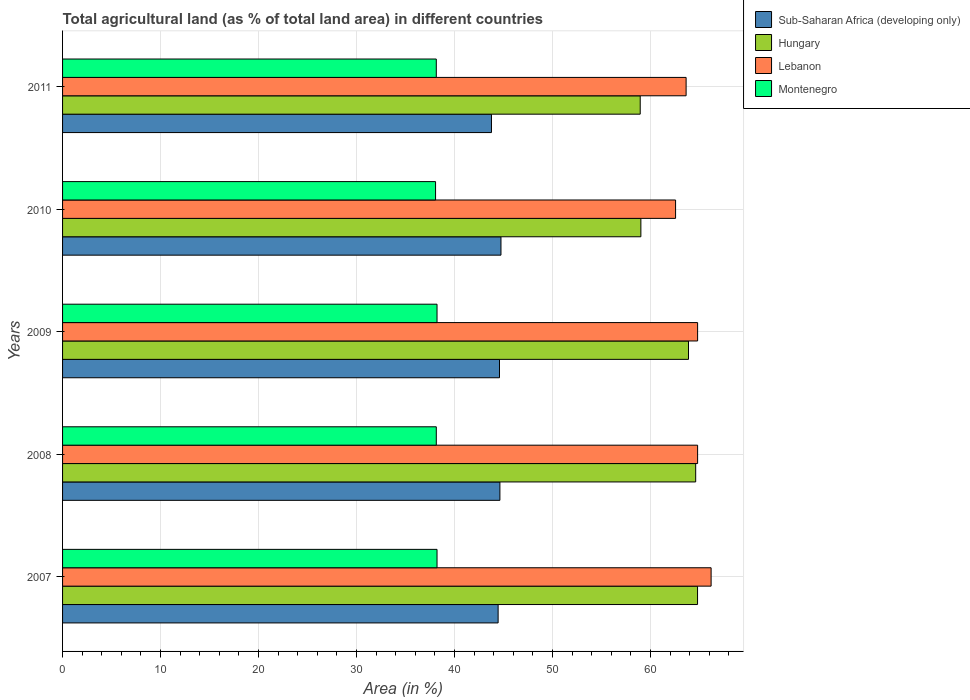How many groups of bars are there?
Give a very brief answer. 5. Are the number of bars per tick equal to the number of legend labels?
Give a very brief answer. Yes. What is the percentage of agricultural land in Hungary in 2011?
Your answer should be very brief. 58.95. Across all years, what is the maximum percentage of agricultural land in Hungary?
Your response must be concise. 64.8. Across all years, what is the minimum percentage of agricultural land in Hungary?
Give a very brief answer. 58.95. In which year was the percentage of agricultural land in Montenegro maximum?
Offer a terse response. 2007. In which year was the percentage of agricultural land in Hungary minimum?
Make the answer very short. 2011. What is the total percentage of agricultural land in Lebanon in the graph?
Make the answer very short. 322. What is the difference between the percentage of agricultural land in Lebanon in 2009 and that in 2011?
Offer a terse response. 1.17. What is the difference between the percentage of agricultural land in Sub-Saharan Africa (developing only) in 2011 and the percentage of agricultural land in Hungary in 2008?
Give a very brief answer. -20.84. What is the average percentage of agricultural land in Sub-Saharan Africa (developing only) per year?
Keep it short and to the point. 44.44. In the year 2007, what is the difference between the percentage of agricultural land in Hungary and percentage of agricultural land in Sub-Saharan Africa (developing only)?
Your response must be concise. 20.35. What is the ratio of the percentage of agricultural land in Montenegro in 2010 to that in 2011?
Make the answer very short. 1. Is the difference between the percentage of agricultural land in Hungary in 2007 and 2008 greater than the difference between the percentage of agricultural land in Sub-Saharan Africa (developing only) in 2007 and 2008?
Keep it short and to the point. Yes. What is the difference between the highest and the second highest percentage of agricultural land in Sub-Saharan Africa (developing only)?
Offer a terse response. 0.11. What is the difference between the highest and the lowest percentage of agricultural land in Sub-Saharan Africa (developing only)?
Ensure brevity in your answer.  0.97. In how many years, is the percentage of agricultural land in Montenegro greater than the average percentage of agricultural land in Montenegro taken over all years?
Provide a short and direct response. 2. Is the sum of the percentage of agricultural land in Hungary in 2008 and 2010 greater than the maximum percentage of agricultural land in Lebanon across all years?
Give a very brief answer. Yes. Is it the case that in every year, the sum of the percentage of agricultural land in Lebanon and percentage of agricultural land in Hungary is greater than the sum of percentage of agricultural land in Sub-Saharan Africa (developing only) and percentage of agricultural land in Montenegro?
Give a very brief answer. Yes. What does the 3rd bar from the top in 2010 represents?
Provide a succinct answer. Hungary. What does the 1st bar from the bottom in 2009 represents?
Keep it short and to the point. Sub-Saharan Africa (developing only). How many bars are there?
Give a very brief answer. 20. Does the graph contain grids?
Provide a short and direct response. Yes. Where does the legend appear in the graph?
Your answer should be very brief. Top right. How many legend labels are there?
Offer a very short reply. 4. How are the legend labels stacked?
Your answer should be very brief. Vertical. What is the title of the graph?
Your answer should be compact. Total agricultural land (as % of total land area) in different countries. What is the label or title of the X-axis?
Your answer should be very brief. Area (in %). What is the Area (in %) in Sub-Saharan Africa (developing only) in 2007?
Your response must be concise. 44.45. What is the Area (in %) in Hungary in 2007?
Keep it short and to the point. 64.8. What is the Area (in %) in Lebanon in 2007?
Offer a terse response. 66.19. What is the Area (in %) in Montenegro in 2007?
Offer a terse response. 38.22. What is the Area (in %) of Sub-Saharan Africa (developing only) in 2008?
Keep it short and to the point. 44.63. What is the Area (in %) of Hungary in 2008?
Your answer should be compact. 64.61. What is the Area (in %) of Lebanon in 2008?
Offer a terse response. 64.81. What is the Area (in %) of Montenegro in 2008?
Your answer should be very brief. 38.14. What is the Area (in %) in Sub-Saharan Africa (developing only) in 2009?
Your answer should be very brief. 44.59. What is the Area (in %) of Hungary in 2009?
Provide a succinct answer. 63.88. What is the Area (in %) in Lebanon in 2009?
Ensure brevity in your answer.  64.81. What is the Area (in %) in Montenegro in 2009?
Make the answer very short. 38.22. What is the Area (in %) in Sub-Saharan Africa (developing only) in 2010?
Keep it short and to the point. 44.74. What is the Area (in %) of Hungary in 2010?
Give a very brief answer. 59.02. What is the Area (in %) in Lebanon in 2010?
Keep it short and to the point. 62.56. What is the Area (in %) of Montenegro in 2010?
Give a very brief answer. 38.07. What is the Area (in %) in Sub-Saharan Africa (developing only) in 2011?
Provide a succinct answer. 43.77. What is the Area (in %) in Hungary in 2011?
Make the answer very short. 58.95. What is the Area (in %) in Lebanon in 2011?
Provide a succinct answer. 63.64. What is the Area (in %) of Montenegro in 2011?
Your answer should be very brief. 38.14. Across all years, what is the maximum Area (in %) of Sub-Saharan Africa (developing only)?
Ensure brevity in your answer.  44.74. Across all years, what is the maximum Area (in %) of Hungary?
Offer a terse response. 64.8. Across all years, what is the maximum Area (in %) of Lebanon?
Ensure brevity in your answer.  66.19. Across all years, what is the maximum Area (in %) of Montenegro?
Keep it short and to the point. 38.22. Across all years, what is the minimum Area (in %) in Sub-Saharan Africa (developing only)?
Your response must be concise. 43.77. Across all years, what is the minimum Area (in %) in Hungary?
Provide a short and direct response. 58.95. Across all years, what is the minimum Area (in %) of Lebanon?
Provide a short and direct response. 62.56. Across all years, what is the minimum Area (in %) in Montenegro?
Your answer should be compact. 38.07. What is the total Area (in %) in Sub-Saharan Africa (developing only) in the graph?
Ensure brevity in your answer.  222.19. What is the total Area (in %) in Hungary in the graph?
Keep it short and to the point. 311.27. What is the total Area (in %) in Lebanon in the graph?
Your answer should be very brief. 322. What is the total Area (in %) in Montenegro in the graph?
Offer a terse response. 190.78. What is the difference between the Area (in %) in Sub-Saharan Africa (developing only) in 2007 and that in 2008?
Offer a very short reply. -0.18. What is the difference between the Area (in %) in Hungary in 2007 and that in 2008?
Give a very brief answer. 0.19. What is the difference between the Area (in %) in Lebanon in 2007 and that in 2008?
Give a very brief answer. 1.38. What is the difference between the Area (in %) of Montenegro in 2007 and that in 2008?
Offer a terse response. 0.07. What is the difference between the Area (in %) of Sub-Saharan Africa (developing only) in 2007 and that in 2009?
Offer a terse response. -0.14. What is the difference between the Area (in %) of Hungary in 2007 and that in 2009?
Offer a very short reply. 0.92. What is the difference between the Area (in %) of Lebanon in 2007 and that in 2009?
Make the answer very short. 1.38. What is the difference between the Area (in %) of Montenegro in 2007 and that in 2009?
Provide a succinct answer. 0. What is the difference between the Area (in %) of Sub-Saharan Africa (developing only) in 2007 and that in 2010?
Provide a succinct answer. -0.29. What is the difference between the Area (in %) of Hungary in 2007 and that in 2010?
Provide a short and direct response. 5.78. What is the difference between the Area (in %) in Lebanon in 2007 and that in 2010?
Your answer should be very brief. 3.63. What is the difference between the Area (in %) of Montenegro in 2007 and that in 2010?
Offer a very short reply. 0.15. What is the difference between the Area (in %) in Sub-Saharan Africa (developing only) in 2007 and that in 2011?
Your answer should be very brief. 0.68. What is the difference between the Area (in %) in Hungary in 2007 and that in 2011?
Keep it short and to the point. 5.85. What is the difference between the Area (in %) in Lebanon in 2007 and that in 2011?
Ensure brevity in your answer.  2.55. What is the difference between the Area (in %) in Montenegro in 2007 and that in 2011?
Provide a succinct answer. 0.07. What is the difference between the Area (in %) of Sub-Saharan Africa (developing only) in 2008 and that in 2009?
Your response must be concise. 0.04. What is the difference between the Area (in %) in Hungary in 2008 and that in 2009?
Your response must be concise. 0.73. What is the difference between the Area (in %) in Montenegro in 2008 and that in 2009?
Provide a succinct answer. -0.07. What is the difference between the Area (in %) of Sub-Saharan Africa (developing only) in 2008 and that in 2010?
Provide a succinct answer. -0.11. What is the difference between the Area (in %) in Hungary in 2008 and that in 2010?
Keep it short and to the point. 5.59. What is the difference between the Area (in %) of Lebanon in 2008 and that in 2010?
Offer a terse response. 2.25. What is the difference between the Area (in %) of Montenegro in 2008 and that in 2010?
Provide a succinct answer. 0.07. What is the difference between the Area (in %) of Sub-Saharan Africa (developing only) in 2008 and that in 2011?
Keep it short and to the point. 0.86. What is the difference between the Area (in %) in Hungary in 2008 and that in 2011?
Your answer should be very brief. 5.66. What is the difference between the Area (in %) in Lebanon in 2008 and that in 2011?
Provide a short and direct response. 1.17. What is the difference between the Area (in %) in Montenegro in 2008 and that in 2011?
Keep it short and to the point. 0. What is the difference between the Area (in %) of Sub-Saharan Africa (developing only) in 2009 and that in 2010?
Your response must be concise. -0.15. What is the difference between the Area (in %) of Hungary in 2009 and that in 2010?
Give a very brief answer. 4.86. What is the difference between the Area (in %) of Lebanon in 2009 and that in 2010?
Ensure brevity in your answer.  2.25. What is the difference between the Area (in %) of Montenegro in 2009 and that in 2010?
Give a very brief answer. 0.15. What is the difference between the Area (in %) in Sub-Saharan Africa (developing only) in 2009 and that in 2011?
Offer a terse response. 0.82. What is the difference between the Area (in %) of Hungary in 2009 and that in 2011?
Keep it short and to the point. 4.93. What is the difference between the Area (in %) in Lebanon in 2009 and that in 2011?
Offer a terse response. 1.17. What is the difference between the Area (in %) of Montenegro in 2009 and that in 2011?
Your answer should be compact. 0.07. What is the difference between the Area (in %) of Sub-Saharan Africa (developing only) in 2010 and that in 2011?
Provide a succinct answer. 0.97. What is the difference between the Area (in %) in Hungary in 2010 and that in 2011?
Offer a very short reply. 0.07. What is the difference between the Area (in %) in Lebanon in 2010 and that in 2011?
Make the answer very short. -1.08. What is the difference between the Area (in %) in Montenegro in 2010 and that in 2011?
Your answer should be very brief. -0.07. What is the difference between the Area (in %) in Sub-Saharan Africa (developing only) in 2007 and the Area (in %) in Hungary in 2008?
Offer a very short reply. -20.16. What is the difference between the Area (in %) in Sub-Saharan Africa (developing only) in 2007 and the Area (in %) in Lebanon in 2008?
Make the answer very short. -20.36. What is the difference between the Area (in %) of Sub-Saharan Africa (developing only) in 2007 and the Area (in %) of Montenegro in 2008?
Provide a succinct answer. 6.31. What is the difference between the Area (in %) in Hungary in 2007 and the Area (in %) in Lebanon in 2008?
Give a very brief answer. -0.01. What is the difference between the Area (in %) in Hungary in 2007 and the Area (in %) in Montenegro in 2008?
Provide a succinct answer. 26.66. What is the difference between the Area (in %) of Lebanon in 2007 and the Area (in %) of Montenegro in 2008?
Your response must be concise. 28.05. What is the difference between the Area (in %) in Sub-Saharan Africa (developing only) in 2007 and the Area (in %) in Hungary in 2009?
Give a very brief answer. -19.43. What is the difference between the Area (in %) of Sub-Saharan Africa (developing only) in 2007 and the Area (in %) of Lebanon in 2009?
Your answer should be compact. -20.36. What is the difference between the Area (in %) of Sub-Saharan Africa (developing only) in 2007 and the Area (in %) of Montenegro in 2009?
Provide a short and direct response. 6.23. What is the difference between the Area (in %) of Hungary in 2007 and the Area (in %) of Lebanon in 2009?
Your response must be concise. -0.01. What is the difference between the Area (in %) of Hungary in 2007 and the Area (in %) of Montenegro in 2009?
Provide a short and direct response. 26.59. What is the difference between the Area (in %) in Lebanon in 2007 and the Area (in %) in Montenegro in 2009?
Offer a very short reply. 27.97. What is the difference between the Area (in %) in Sub-Saharan Africa (developing only) in 2007 and the Area (in %) in Hungary in 2010?
Give a very brief answer. -14.57. What is the difference between the Area (in %) in Sub-Saharan Africa (developing only) in 2007 and the Area (in %) in Lebanon in 2010?
Your response must be concise. -18.11. What is the difference between the Area (in %) of Sub-Saharan Africa (developing only) in 2007 and the Area (in %) of Montenegro in 2010?
Your answer should be compact. 6.38. What is the difference between the Area (in %) in Hungary in 2007 and the Area (in %) in Lebanon in 2010?
Give a very brief answer. 2.24. What is the difference between the Area (in %) of Hungary in 2007 and the Area (in %) of Montenegro in 2010?
Offer a terse response. 26.74. What is the difference between the Area (in %) of Lebanon in 2007 and the Area (in %) of Montenegro in 2010?
Your answer should be very brief. 28.12. What is the difference between the Area (in %) of Sub-Saharan Africa (developing only) in 2007 and the Area (in %) of Hungary in 2011?
Your answer should be compact. -14.5. What is the difference between the Area (in %) of Sub-Saharan Africa (developing only) in 2007 and the Area (in %) of Lebanon in 2011?
Provide a short and direct response. -19.19. What is the difference between the Area (in %) of Sub-Saharan Africa (developing only) in 2007 and the Area (in %) of Montenegro in 2011?
Your response must be concise. 6.31. What is the difference between the Area (in %) of Hungary in 2007 and the Area (in %) of Montenegro in 2011?
Provide a short and direct response. 26.66. What is the difference between the Area (in %) in Lebanon in 2007 and the Area (in %) in Montenegro in 2011?
Your answer should be compact. 28.05. What is the difference between the Area (in %) in Sub-Saharan Africa (developing only) in 2008 and the Area (in %) in Hungary in 2009?
Provide a short and direct response. -19.25. What is the difference between the Area (in %) in Sub-Saharan Africa (developing only) in 2008 and the Area (in %) in Lebanon in 2009?
Your response must be concise. -20.18. What is the difference between the Area (in %) of Sub-Saharan Africa (developing only) in 2008 and the Area (in %) of Montenegro in 2009?
Make the answer very short. 6.42. What is the difference between the Area (in %) of Hungary in 2008 and the Area (in %) of Lebanon in 2009?
Offer a very short reply. -0.2. What is the difference between the Area (in %) of Hungary in 2008 and the Area (in %) of Montenegro in 2009?
Provide a succinct answer. 26.4. What is the difference between the Area (in %) of Lebanon in 2008 and the Area (in %) of Montenegro in 2009?
Offer a terse response. 26.59. What is the difference between the Area (in %) in Sub-Saharan Africa (developing only) in 2008 and the Area (in %) in Hungary in 2010?
Your response must be concise. -14.39. What is the difference between the Area (in %) of Sub-Saharan Africa (developing only) in 2008 and the Area (in %) of Lebanon in 2010?
Give a very brief answer. -17.93. What is the difference between the Area (in %) of Sub-Saharan Africa (developing only) in 2008 and the Area (in %) of Montenegro in 2010?
Provide a succinct answer. 6.57. What is the difference between the Area (in %) in Hungary in 2008 and the Area (in %) in Lebanon in 2010?
Give a very brief answer. 2.05. What is the difference between the Area (in %) in Hungary in 2008 and the Area (in %) in Montenegro in 2010?
Offer a very short reply. 26.55. What is the difference between the Area (in %) of Lebanon in 2008 and the Area (in %) of Montenegro in 2010?
Your answer should be compact. 26.74. What is the difference between the Area (in %) in Sub-Saharan Africa (developing only) in 2008 and the Area (in %) in Hungary in 2011?
Provide a succinct answer. -14.32. What is the difference between the Area (in %) in Sub-Saharan Africa (developing only) in 2008 and the Area (in %) in Lebanon in 2011?
Offer a very short reply. -19. What is the difference between the Area (in %) in Sub-Saharan Africa (developing only) in 2008 and the Area (in %) in Montenegro in 2011?
Provide a succinct answer. 6.49. What is the difference between the Area (in %) in Hungary in 2008 and the Area (in %) in Lebanon in 2011?
Your answer should be compact. 0.98. What is the difference between the Area (in %) in Hungary in 2008 and the Area (in %) in Montenegro in 2011?
Your response must be concise. 26.47. What is the difference between the Area (in %) in Lebanon in 2008 and the Area (in %) in Montenegro in 2011?
Provide a succinct answer. 26.67. What is the difference between the Area (in %) of Sub-Saharan Africa (developing only) in 2009 and the Area (in %) of Hungary in 2010?
Keep it short and to the point. -14.43. What is the difference between the Area (in %) of Sub-Saharan Africa (developing only) in 2009 and the Area (in %) of Lebanon in 2010?
Your answer should be very brief. -17.97. What is the difference between the Area (in %) of Sub-Saharan Africa (developing only) in 2009 and the Area (in %) of Montenegro in 2010?
Provide a succinct answer. 6.53. What is the difference between the Area (in %) in Hungary in 2009 and the Area (in %) in Lebanon in 2010?
Offer a terse response. 1.32. What is the difference between the Area (in %) in Hungary in 2009 and the Area (in %) in Montenegro in 2010?
Provide a succinct answer. 25.81. What is the difference between the Area (in %) of Lebanon in 2009 and the Area (in %) of Montenegro in 2010?
Make the answer very short. 26.74. What is the difference between the Area (in %) of Sub-Saharan Africa (developing only) in 2009 and the Area (in %) of Hungary in 2011?
Your answer should be very brief. -14.36. What is the difference between the Area (in %) of Sub-Saharan Africa (developing only) in 2009 and the Area (in %) of Lebanon in 2011?
Your answer should be very brief. -19.04. What is the difference between the Area (in %) in Sub-Saharan Africa (developing only) in 2009 and the Area (in %) in Montenegro in 2011?
Make the answer very short. 6.45. What is the difference between the Area (in %) in Hungary in 2009 and the Area (in %) in Lebanon in 2011?
Your answer should be compact. 0.24. What is the difference between the Area (in %) of Hungary in 2009 and the Area (in %) of Montenegro in 2011?
Offer a very short reply. 25.74. What is the difference between the Area (in %) of Lebanon in 2009 and the Area (in %) of Montenegro in 2011?
Offer a very short reply. 26.67. What is the difference between the Area (in %) of Sub-Saharan Africa (developing only) in 2010 and the Area (in %) of Hungary in 2011?
Your answer should be very brief. -14.21. What is the difference between the Area (in %) of Sub-Saharan Africa (developing only) in 2010 and the Area (in %) of Lebanon in 2011?
Offer a very short reply. -18.89. What is the difference between the Area (in %) in Sub-Saharan Africa (developing only) in 2010 and the Area (in %) in Montenegro in 2011?
Make the answer very short. 6.6. What is the difference between the Area (in %) of Hungary in 2010 and the Area (in %) of Lebanon in 2011?
Provide a succinct answer. -4.62. What is the difference between the Area (in %) in Hungary in 2010 and the Area (in %) in Montenegro in 2011?
Your answer should be very brief. 20.88. What is the difference between the Area (in %) of Lebanon in 2010 and the Area (in %) of Montenegro in 2011?
Provide a short and direct response. 24.42. What is the average Area (in %) in Sub-Saharan Africa (developing only) per year?
Your response must be concise. 44.44. What is the average Area (in %) of Hungary per year?
Make the answer very short. 62.25. What is the average Area (in %) of Lebanon per year?
Keep it short and to the point. 64.4. What is the average Area (in %) in Montenegro per year?
Give a very brief answer. 38.16. In the year 2007, what is the difference between the Area (in %) in Sub-Saharan Africa (developing only) and Area (in %) in Hungary?
Your answer should be very brief. -20.35. In the year 2007, what is the difference between the Area (in %) of Sub-Saharan Africa (developing only) and Area (in %) of Lebanon?
Provide a short and direct response. -21.74. In the year 2007, what is the difference between the Area (in %) in Sub-Saharan Africa (developing only) and Area (in %) in Montenegro?
Make the answer very short. 6.23. In the year 2007, what is the difference between the Area (in %) of Hungary and Area (in %) of Lebanon?
Your answer should be compact. -1.38. In the year 2007, what is the difference between the Area (in %) in Hungary and Area (in %) in Montenegro?
Ensure brevity in your answer.  26.59. In the year 2007, what is the difference between the Area (in %) in Lebanon and Area (in %) in Montenegro?
Offer a very short reply. 27.97. In the year 2008, what is the difference between the Area (in %) of Sub-Saharan Africa (developing only) and Area (in %) of Hungary?
Provide a succinct answer. -19.98. In the year 2008, what is the difference between the Area (in %) in Sub-Saharan Africa (developing only) and Area (in %) in Lebanon?
Offer a terse response. -20.18. In the year 2008, what is the difference between the Area (in %) of Sub-Saharan Africa (developing only) and Area (in %) of Montenegro?
Your answer should be compact. 6.49. In the year 2008, what is the difference between the Area (in %) in Hungary and Area (in %) in Lebanon?
Your answer should be compact. -0.2. In the year 2008, what is the difference between the Area (in %) of Hungary and Area (in %) of Montenegro?
Give a very brief answer. 26.47. In the year 2008, what is the difference between the Area (in %) in Lebanon and Area (in %) in Montenegro?
Offer a terse response. 26.67. In the year 2009, what is the difference between the Area (in %) in Sub-Saharan Africa (developing only) and Area (in %) in Hungary?
Offer a terse response. -19.29. In the year 2009, what is the difference between the Area (in %) in Sub-Saharan Africa (developing only) and Area (in %) in Lebanon?
Your response must be concise. -20.22. In the year 2009, what is the difference between the Area (in %) in Sub-Saharan Africa (developing only) and Area (in %) in Montenegro?
Offer a terse response. 6.38. In the year 2009, what is the difference between the Area (in %) in Hungary and Area (in %) in Lebanon?
Offer a very short reply. -0.93. In the year 2009, what is the difference between the Area (in %) of Hungary and Area (in %) of Montenegro?
Your response must be concise. 25.66. In the year 2009, what is the difference between the Area (in %) of Lebanon and Area (in %) of Montenegro?
Your answer should be very brief. 26.59. In the year 2010, what is the difference between the Area (in %) of Sub-Saharan Africa (developing only) and Area (in %) of Hungary?
Give a very brief answer. -14.28. In the year 2010, what is the difference between the Area (in %) in Sub-Saharan Africa (developing only) and Area (in %) in Lebanon?
Provide a short and direct response. -17.82. In the year 2010, what is the difference between the Area (in %) in Sub-Saharan Africa (developing only) and Area (in %) in Montenegro?
Provide a succinct answer. 6.67. In the year 2010, what is the difference between the Area (in %) in Hungary and Area (in %) in Lebanon?
Your answer should be compact. -3.54. In the year 2010, what is the difference between the Area (in %) in Hungary and Area (in %) in Montenegro?
Provide a short and direct response. 20.95. In the year 2010, what is the difference between the Area (in %) of Lebanon and Area (in %) of Montenegro?
Keep it short and to the point. 24.49. In the year 2011, what is the difference between the Area (in %) in Sub-Saharan Africa (developing only) and Area (in %) in Hungary?
Your answer should be compact. -15.18. In the year 2011, what is the difference between the Area (in %) of Sub-Saharan Africa (developing only) and Area (in %) of Lebanon?
Keep it short and to the point. -19.86. In the year 2011, what is the difference between the Area (in %) in Sub-Saharan Africa (developing only) and Area (in %) in Montenegro?
Keep it short and to the point. 5.63. In the year 2011, what is the difference between the Area (in %) in Hungary and Area (in %) in Lebanon?
Give a very brief answer. -4.68. In the year 2011, what is the difference between the Area (in %) of Hungary and Area (in %) of Montenegro?
Give a very brief answer. 20.81. In the year 2011, what is the difference between the Area (in %) in Lebanon and Area (in %) in Montenegro?
Your answer should be very brief. 25.5. What is the ratio of the Area (in %) of Lebanon in 2007 to that in 2008?
Give a very brief answer. 1.02. What is the ratio of the Area (in %) of Sub-Saharan Africa (developing only) in 2007 to that in 2009?
Give a very brief answer. 1. What is the ratio of the Area (in %) of Hungary in 2007 to that in 2009?
Provide a succinct answer. 1.01. What is the ratio of the Area (in %) of Lebanon in 2007 to that in 2009?
Give a very brief answer. 1.02. What is the ratio of the Area (in %) of Hungary in 2007 to that in 2010?
Provide a succinct answer. 1.1. What is the ratio of the Area (in %) of Lebanon in 2007 to that in 2010?
Your answer should be compact. 1.06. What is the ratio of the Area (in %) in Montenegro in 2007 to that in 2010?
Your response must be concise. 1. What is the ratio of the Area (in %) in Sub-Saharan Africa (developing only) in 2007 to that in 2011?
Your answer should be very brief. 1.02. What is the ratio of the Area (in %) in Hungary in 2007 to that in 2011?
Give a very brief answer. 1.1. What is the ratio of the Area (in %) of Lebanon in 2007 to that in 2011?
Give a very brief answer. 1.04. What is the ratio of the Area (in %) of Montenegro in 2007 to that in 2011?
Your answer should be compact. 1. What is the ratio of the Area (in %) of Sub-Saharan Africa (developing only) in 2008 to that in 2009?
Make the answer very short. 1. What is the ratio of the Area (in %) in Hungary in 2008 to that in 2009?
Offer a very short reply. 1.01. What is the ratio of the Area (in %) in Montenegro in 2008 to that in 2009?
Offer a terse response. 1. What is the ratio of the Area (in %) in Sub-Saharan Africa (developing only) in 2008 to that in 2010?
Your answer should be very brief. 1. What is the ratio of the Area (in %) in Hungary in 2008 to that in 2010?
Offer a very short reply. 1.09. What is the ratio of the Area (in %) of Lebanon in 2008 to that in 2010?
Offer a very short reply. 1.04. What is the ratio of the Area (in %) in Sub-Saharan Africa (developing only) in 2008 to that in 2011?
Offer a very short reply. 1.02. What is the ratio of the Area (in %) of Hungary in 2008 to that in 2011?
Offer a terse response. 1.1. What is the ratio of the Area (in %) of Lebanon in 2008 to that in 2011?
Offer a very short reply. 1.02. What is the ratio of the Area (in %) in Hungary in 2009 to that in 2010?
Your answer should be very brief. 1.08. What is the ratio of the Area (in %) of Lebanon in 2009 to that in 2010?
Give a very brief answer. 1.04. What is the ratio of the Area (in %) in Sub-Saharan Africa (developing only) in 2009 to that in 2011?
Offer a terse response. 1.02. What is the ratio of the Area (in %) of Hungary in 2009 to that in 2011?
Keep it short and to the point. 1.08. What is the ratio of the Area (in %) of Lebanon in 2009 to that in 2011?
Provide a succinct answer. 1.02. What is the ratio of the Area (in %) in Sub-Saharan Africa (developing only) in 2010 to that in 2011?
Keep it short and to the point. 1.02. What is the ratio of the Area (in %) of Lebanon in 2010 to that in 2011?
Offer a terse response. 0.98. What is the ratio of the Area (in %) in Montenegro in 2010 to that in 2011?
Your answer should be compact. 1. What is the difference between the highest and the second highest Area (in %) of Sub-Saharan Africa (developing only)?
Provide a short and direct response. 0.11. What is the difference between the highest and the second highest Area (in %) of Hungary?
Your response must be concise. 0.19. What is the difference between the highest and the second highest Area (in %) of Lebanon?
Your response must be concise. 1.38. What is the difference between the highest and the second highest Area (in %) in Montenegro?
Offer a very short reply. 0. What is the difference between the highest and the lowest Area (in %) of Sub-Saharan Africa (developing only)?
Offer a terse response. 0.97. What is the difference between the highest and the lowest Area (in %) of Hungary?
Your response must be concise. 5.85. What is the difference between the highest and the lowest Area (in %) in Lebanon?
Offer a terse response. 3.63. What is the difference between the highest and the lowest Area (in %) of Montenegro?
Ensure brevity in your answer.  0.15. 